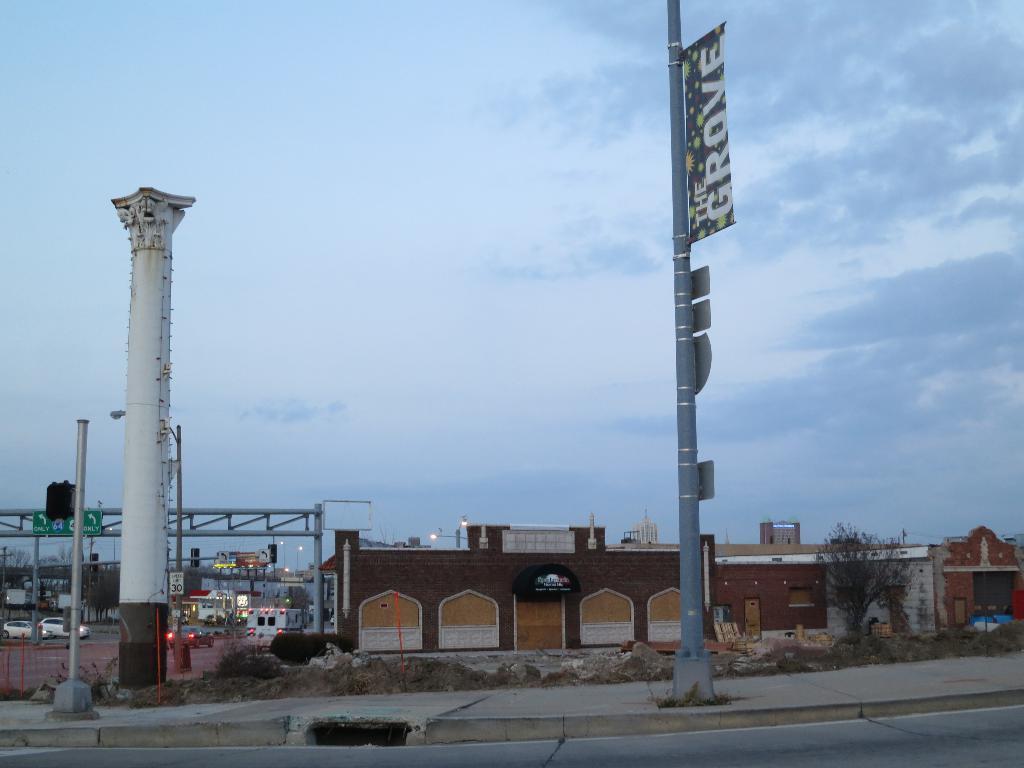Could you give a brief overview of what you see in this image? In the foreground of the image we can see the road and footpath. In the middle of the image we can see houses and cars. On the top of the image we can see the sky. 